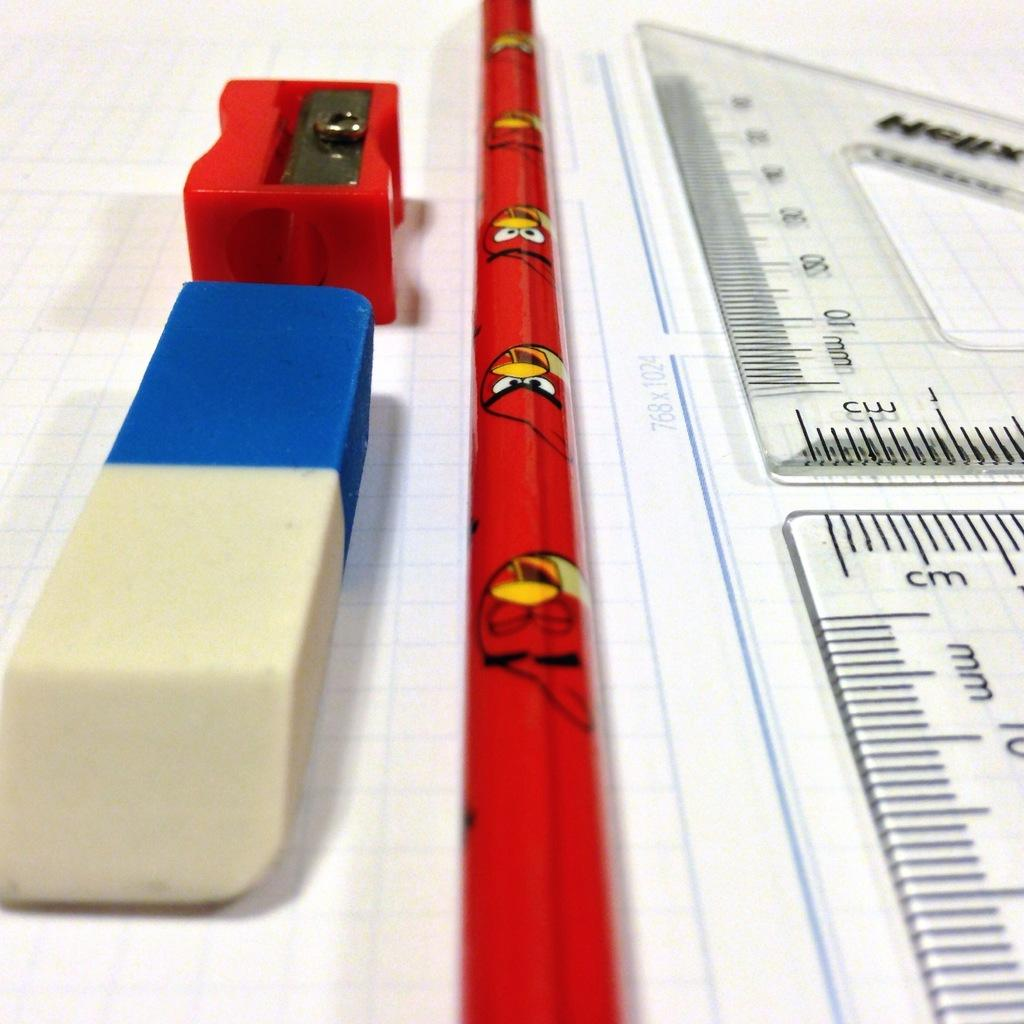Provide a one-sentence caption for the provided image. A roll of angry bird wrapping paper and drawing supplies with a 768x1024 measurement. 